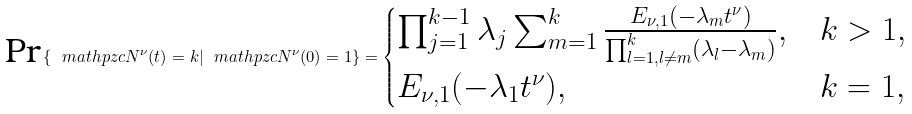<formula> <loc_0><loc_0><loc_500><loc_500>\text {Pr} \left \{ \ m a t h p z c { N } ^ { \nu } ( t ) = k | \ m a t h p z c { N } ^ { \nu } ( 0 ) = 1 \right \} = \begin{cases} \prod _ { j = 1 } ^ { k - 1 } \lambda _ { j } \sum _ { m = 1 } ^ { k } \frac { E _ { \nu , 1 } ( - \lambda _ { m } t ^ { \nu } ) } { \prod _ { l = 1 , l \neq m } ^ { k } \left ( \lambda _ { l } - \lambda _ { m } \right ) } , & k > 1 , \\ E _ { \nu , 1 } ( - \lambda _ { 1 } t ^ { \nu } ) , & k = 1 , \end{cases}</formula> 